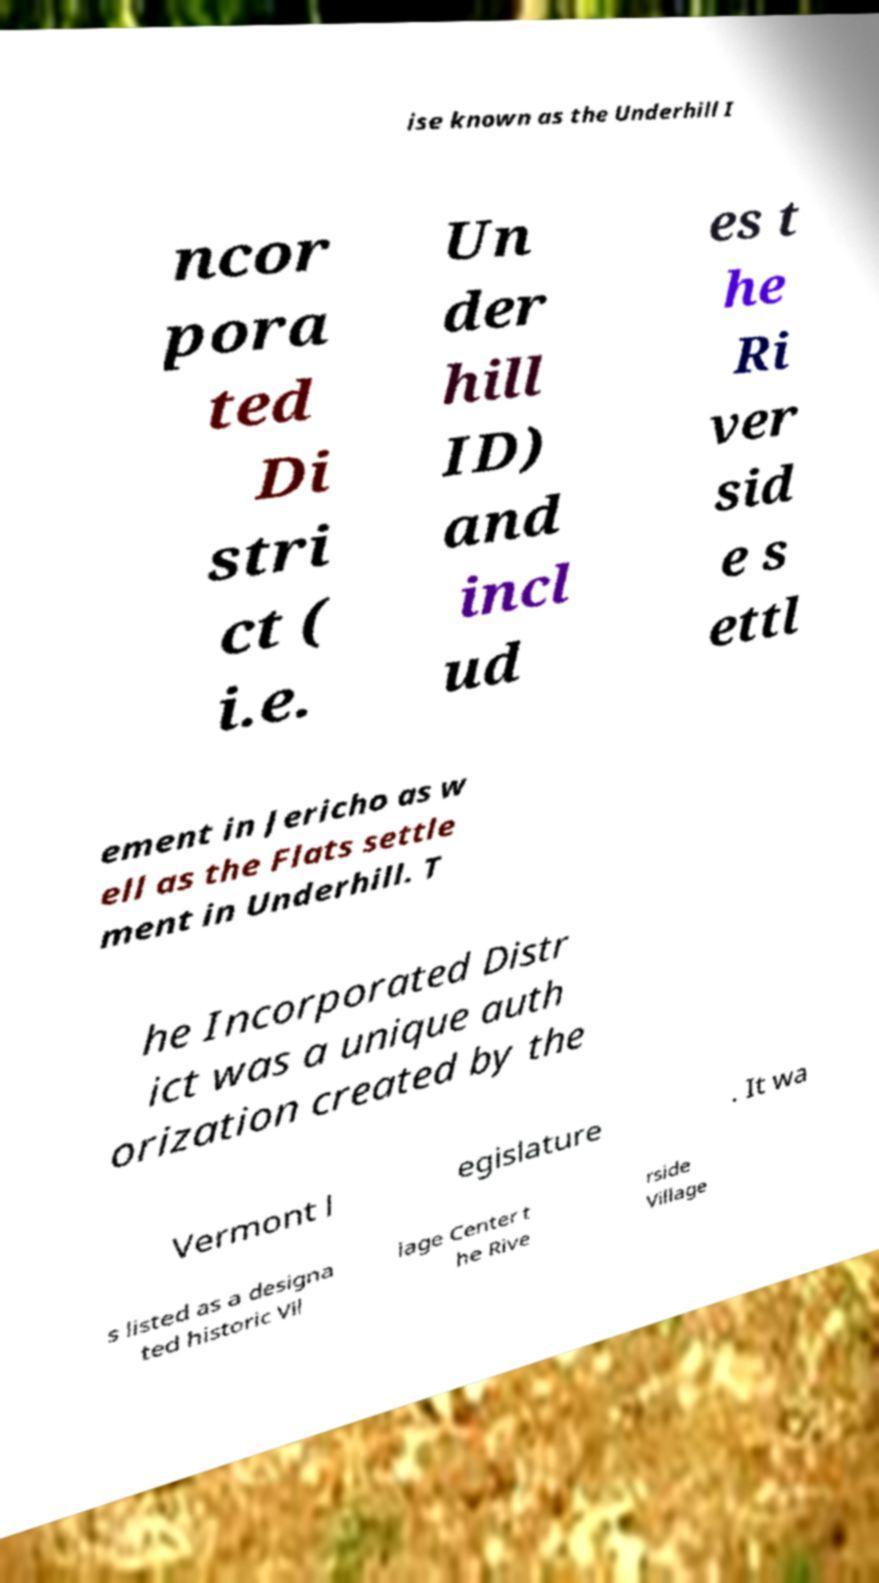Please read and relay the text visible in this image. What does it say? ise known as the Underhill I ncor pora ted Di stri ct ( i.e. Un der hill ID) and incl ud es t he Ri ver sid e s ettl ement in Jericho as w ell as the Flats settle ment in Underhill. T he Incorporated Distr ict was a unique auth orization created by the Vermont l egislature . It wa s listed as a designa ted historic Vil lage Center t he Rive rside Village 